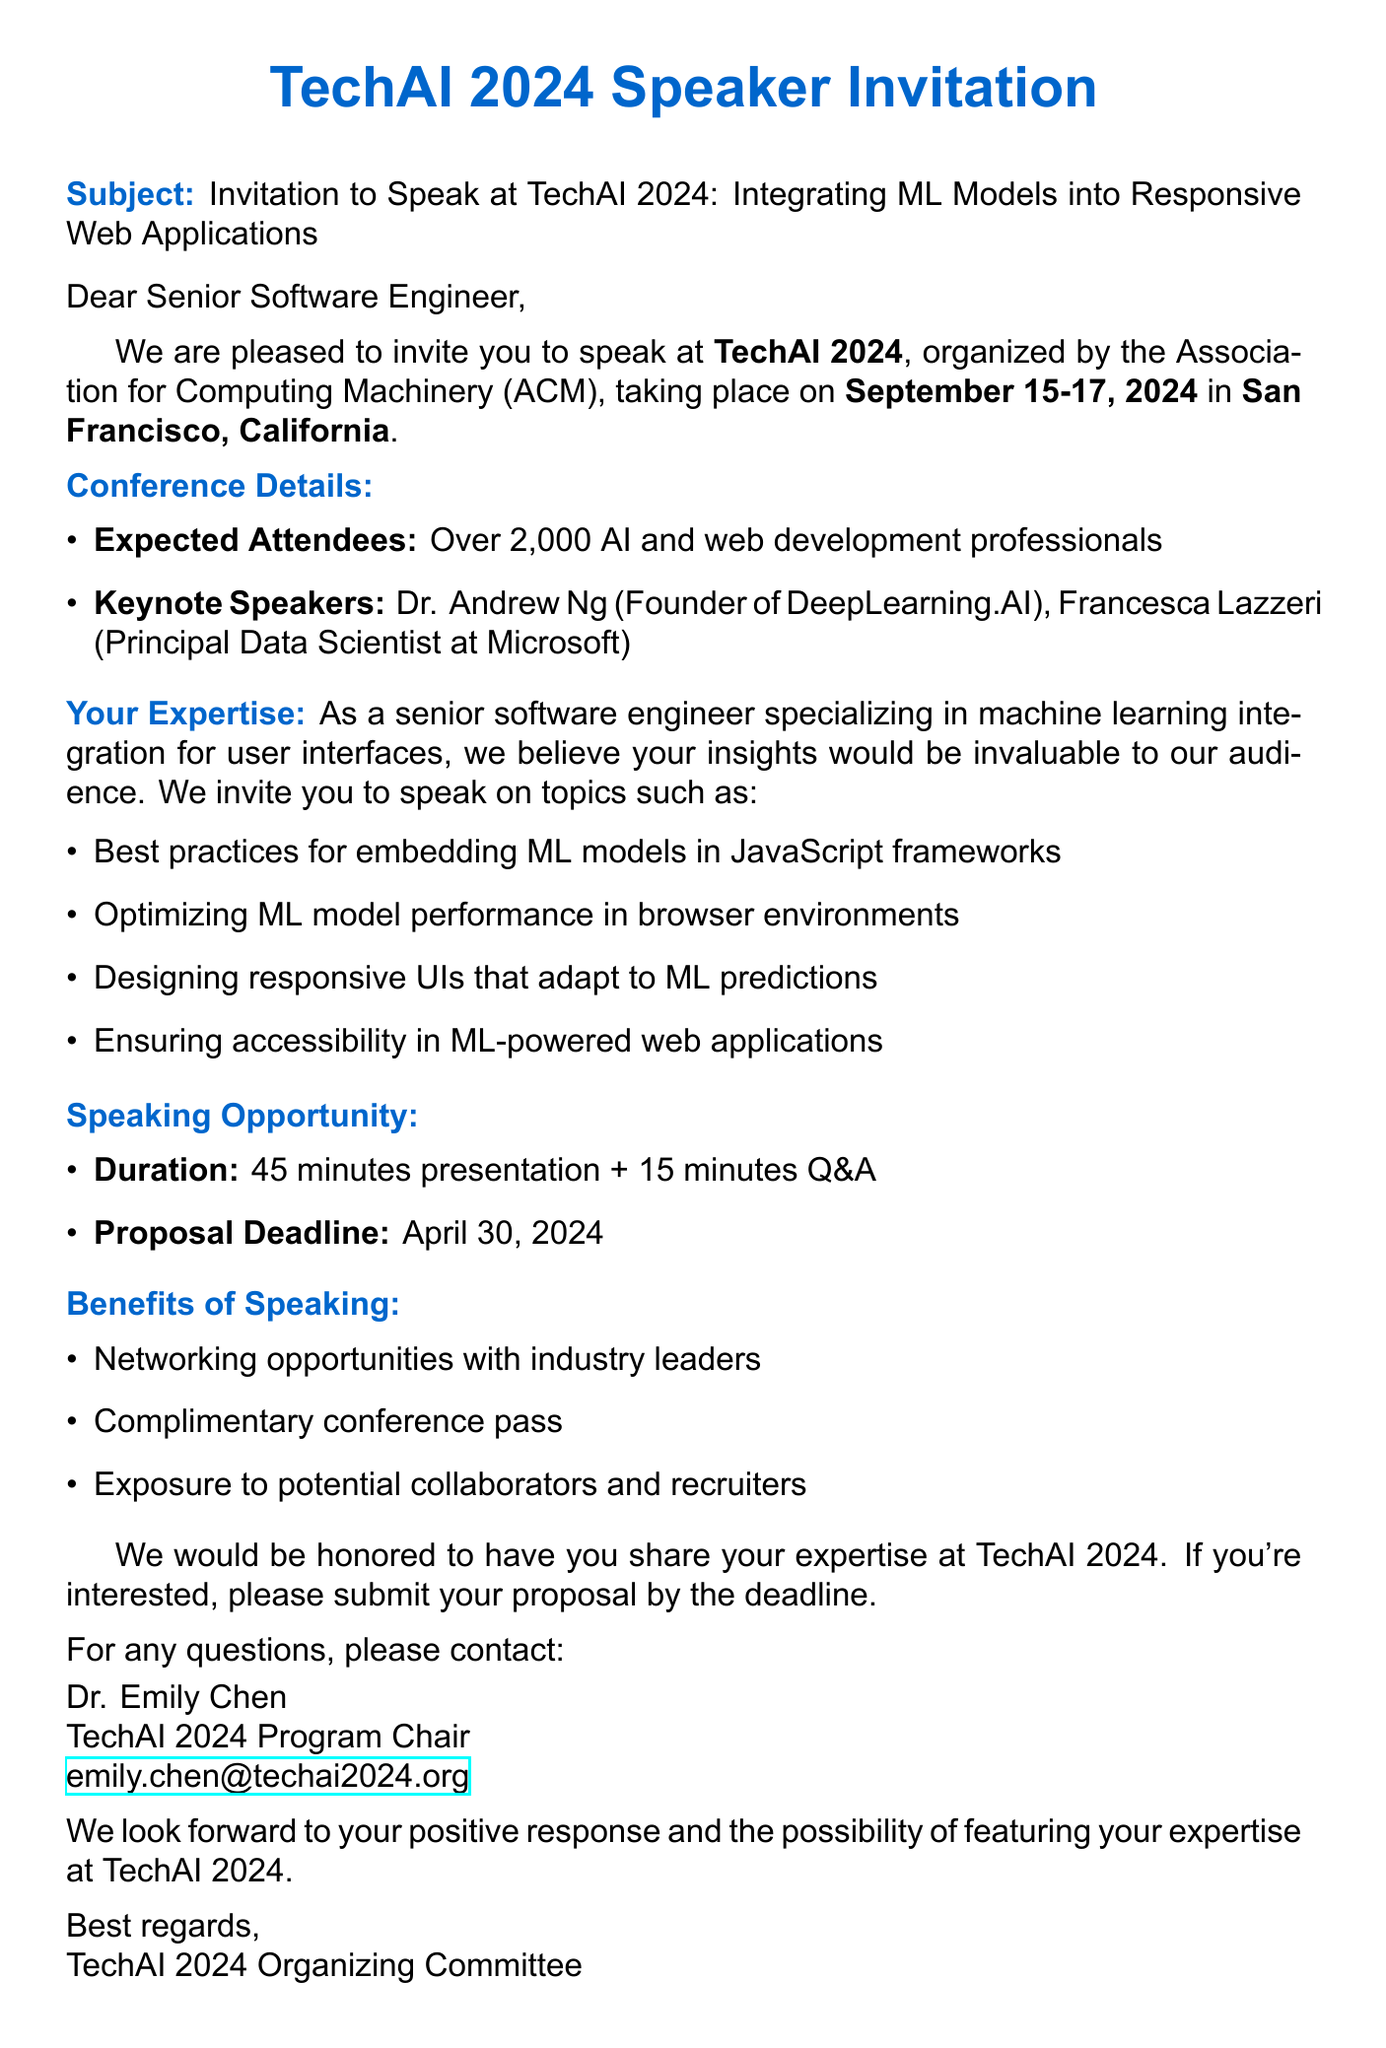What is the conference name? The conference name is explicitly mentioned in the email as TechAI 2024.
Answer: TechAI 2024 What are the conference dates? The email specifies that the conference will take place from September 15-17, 2024.
Answer: September 15-17, 2024 Who is the contact person for the conference? The email provides the name and title of the contact person as Dr. Emily Chen, TechAI 2024 Program Chair.
Answer: Dr. Emily Chen What is the duration of the speaking opportunity? The document outlines a duration of 45 minutes for the presentation plus an additional 15 minutes for Q&A.
Answer: 45 minutes + 15 minutes Q&A What is the deadline for proposal submission? The email states that the deadline for proposal submission is April 30, 2024.
Answer: April 30, 2024 What is one benefit of speaking at the conference? The email lists several benefits, one of which is networking opportunities with industry leaders.
Answer: Networking opportunities with industry leaders How many expected attendees are there? The document indicates that there will be over 2,000 AI and web development professionals attending.
Answer: Over 2,000 What topics are suggested for speaking? The email provides several suggested topics, including best practices for embedding ML models in JavaScript frameworks.
Answer: Best practices for embedding ML models in JavaScript frameworks 